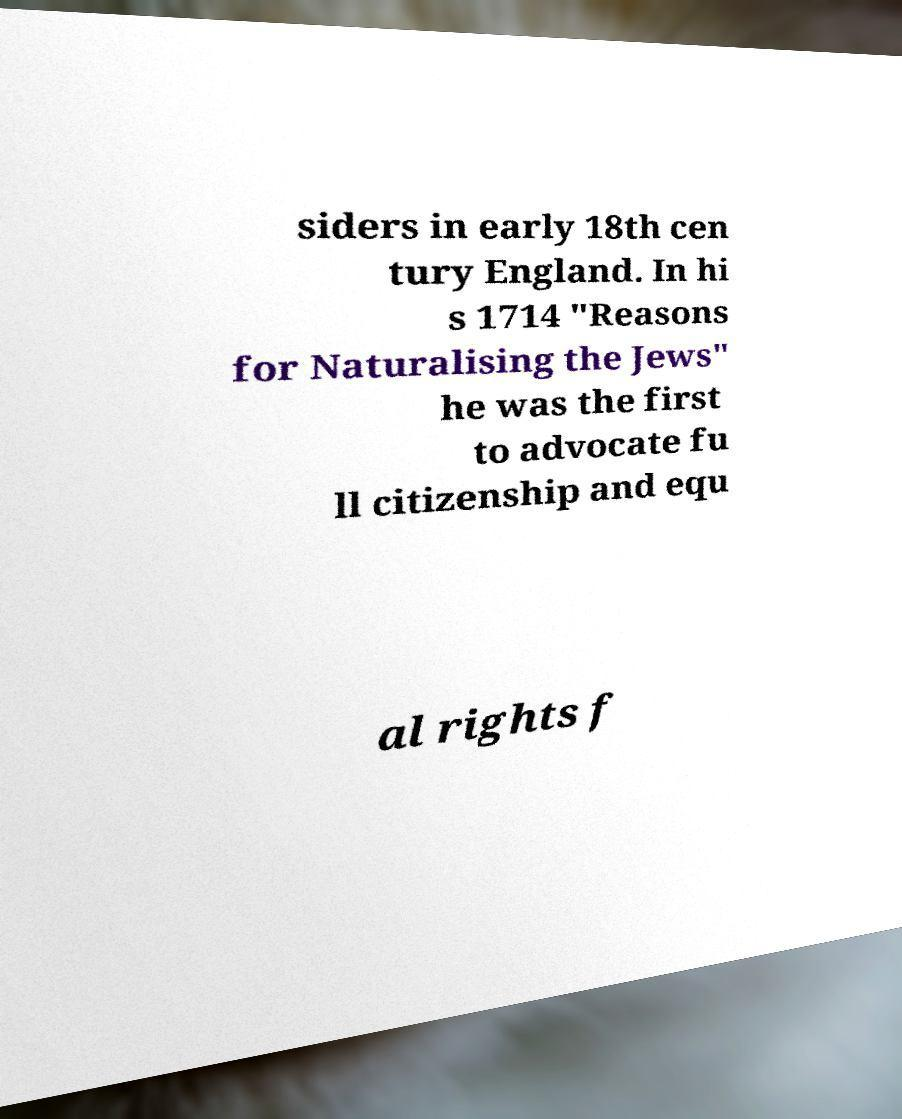I need the written content from this picture converted into text. Can you do that? siders in early 18th cen tury England. In hi s 1714 "Reasons for Naturalising the Jews" he was the first to advocate fu ll citizenship and equ al rights f 